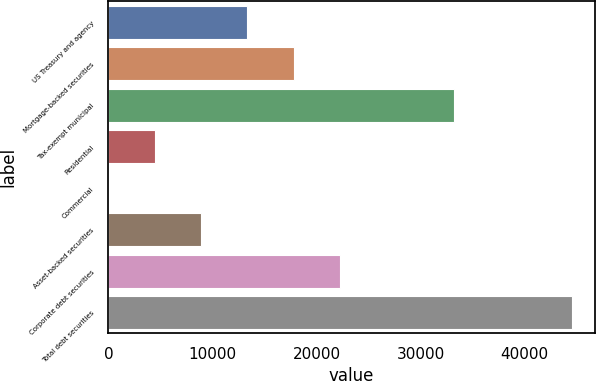Convert chart. <chart><loc_0><loc_0><loc_500><loc_500><bar_chart><fcel>US Treasury and agency<fcel>Mortgage-backed securities<fcel>Tax-exempt municipal<fcel>Residential<fcel>Commercial<fcel>Asset-backed securities<fcel>Corporate debt securities<fcel>Total debt securities<nl><fcel>13350.5<fcel>17800.6<fcel>33218<fcel>4450.39<fcel>0.32<fcel>8900.46<fcel>22250.7<fcel>44501<nl></chart> 